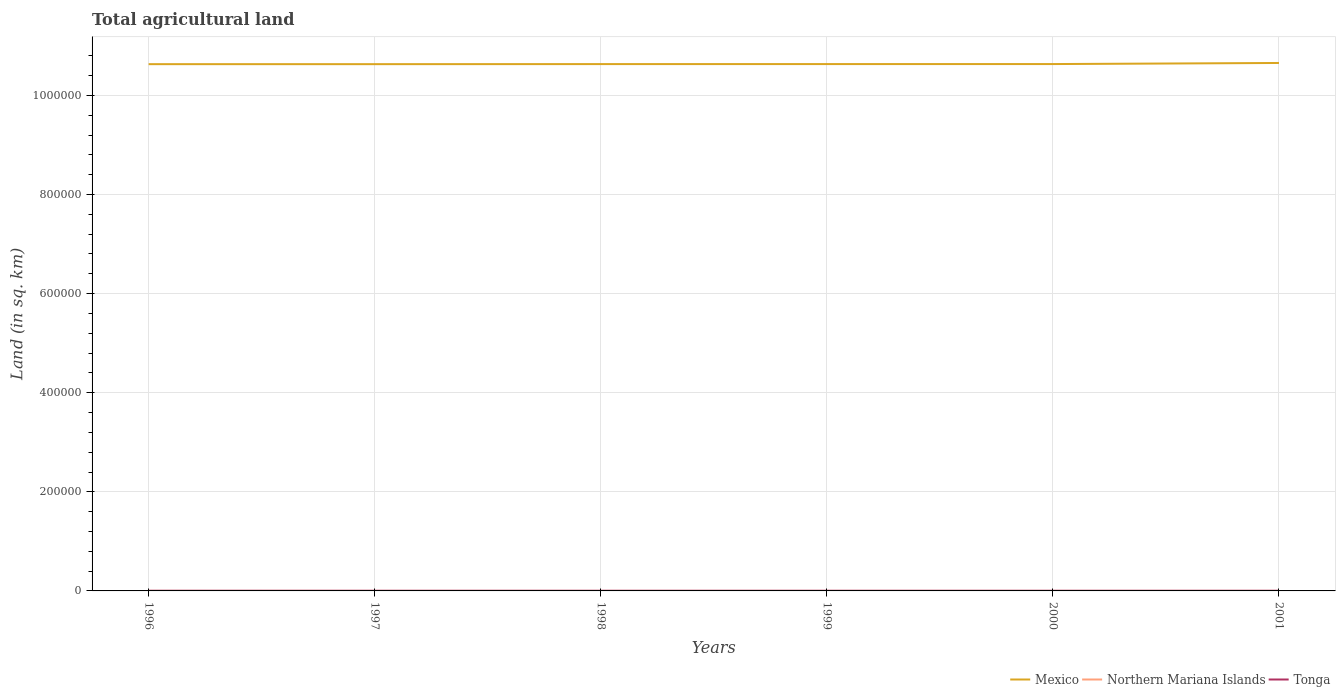How many different coloured lines are there?
Offer a very short reply. 3. Across all years, what is the maximum total agricultural land in Northern Mariana Islands?
Make the answer very short. 30. In which year was the total agricultural land in Tonga maximum?
Your answer should be very brief. 2000. What is the total total agricultural land in Mexico in the graph?
Offer a terse response. -200. What is the difference between the highest and the second highest total agricultural land in Tonga?
Provide a succinct answer. 30. What is the difference between two consecutive major ticks on the Y-axis?
Make the answer very short. 2.00e+05. Are the values on the major ticks of Y-axis written in scientific E-notation?
Keep it short and to the point. No. Does the graph contain grids?
Keep it short and to the point. Yes. How are the legend labels stacked?
Your answer should be very brief. Horizontal. What is the title of the graph?
Ensure brevity in your answer.  Total agricultural land. What is the label or title of the Y-axis?
Make the answer very short. Land (in sq. km). What is the Land (in sq. km) in Mexico in 1996?
Provide a succinct answer. 1.06e+06. What is the Land (in sq. km) of Northern Mariana Islands in 1996?
Provide a succinct answer. 40. What is the Land (in sq. km) of Tonga in 1996?
Offer a terse response. 330. What is the Land (in sq. km) in Mexico in 1997?
Keep it short and to the point. 1.06e+06. What is the Land (in sq. km) in Northern Mariana Islands in 1997?
Your answer should be compact. 40. What is the Land (in sq. km) of Tonga in 1997?
Your response must be concise. 310. What is the Land (in sq. km) of Mexico in 1998?
Provide a short and direct response. 1.06e+06. What is the Land (in sq. km) in Tonga in 1998?
Your answer should be compact. 310. What is the Land (in sq. km) of Mexico in 1999?
Keep it short and to the point. 1.06e+06. What is the Land (in sq. km) in Northern Mariana Islands in 1999?
Offer a terse response. 30. What is the Land (in sq. km) in Tonga in 1999?
Provide a short and direct response. 310. What is the Land (in sq. km) in Mexico in 2000?
Ensure brevity in your answer.  1.06e+06. What is the Land (in sq. km) in Tonga in 2000?
Your response must be concise. 300. What is the Land (in sq. km) in Mexico in 2001?
Offer a terse response. 1.07e+06. What is the Land (in sq. km) of Northern Mariana Islands in 2001?
Give a very brief answer. 30. What is the Land (in sq. km) of Tonga in 2001?
Your answer should be very brief. 300. Across all years, what is the maximum Land (in sq. km) in Mexico?
Your response must be concise. 1.07e+06. Across all years, what is the maximum Land (in sq. km) of Tonga?
Ensure brevity in your answer.  330. Across all years, what is the minimum Land (in sq. km) in Mexico?
Your answer should be compact. 1.06e+06. Across all years, what is the minimum Land (in sq. km) of Northern Mariana Islands?
Ensure brevity in your answer.  30. Across all years, what is the minimum Land (in sq. km) of Tonga?
Provide a succinct answer. 300. What is the total Land (in sq. km) of Mexico in the graph?
Give a very brief answer. 6.38e+06. What is the total Land (in sq. km) in Northern Mariana Islands in the graph?
Offer a terse response. 200. What is the total Land (in sq. km) of Tonga in the graph?
Give a very brief answer. 1860. What is the difference between the Land (in sq. km) in Mexico in 1996 and that in 1997?
Give a very brief answer. 0. What is the difference between the Land (in sq. km) in Tonga in 1996 and that in 1997?
Give a very brief answer. 20. What is the difference between the Land (in sq. km) in Mexico in 1996 and that in 1998?
Make the answer very short. -150. What is the difference between the Land (in sq. km) of Mexico in 1996 and that in 1999?
Ensure brevity in your answer.  -160. What is the difference between the Land (in sq. km) in Northern Mariana Islands in 1996 and that in 1999?
Provide a short and direct response. 10. What is the difference between the Land (in sq. km) in Tonga in 1996 and that in 1999?
Your answer should be compact. 20. What is the difference between the Land (in sq. km) in Mexico in 1996 and that in 2000?
Give a very brief answer. -200. What is the difference between the Land (in sq. km) of Mexico in 1996 and that in 2001?
Keep it short and to the point. -2400. What is the difference between the Land (in sq. km) of Mexico in 1997 and that in 1998?
Your response must be concise. -150. What is the difference between the Land (in sq. km) of Northern Mariana Islands in 1997 and that in 1998?
Your answer should be compact. 10. What is the difference between the Land (in sq. km) of Mexico in 1997 and that in 1999?
Provide a succinct answer. -160. What is the difference between the Land (in sq. km) in Northern Mariana Islands in 1997 and that in 1999?
Offer a very short reply. 10. What is the difference between the Land (in sq. km) in Mexico in 1997 and that in 2000?
Keep it short and to the point. -200. What is the difference between the Land (in sq. km) in Northern Mariana Islands in 1997 and that in 2000?
Your response must be concise. 10. What is the difference between the Land (in sq. km) in Tonga in 1997 and that in 2000?
Ensure brevity in your answer.  10. What is the difference between the Land (in sq. km) of Mexico in 1997 and that in 2001?
Your answer should be very brief. -2400. What is the difference between the Land (in sq. km) of Northern Mariana Islands in 1997 and that in 2001?
Keep it short and to the point. 10. What is the difference between the Land (in sq. km) in Northern Mariana Islands in 1998 and that in 1999?
Ensure brevity in your answer.  0. What is the difference between the Land (in sq. km) of Mexico in 1998 and that in 2000?
Give a very brief answer. -50. What is the difference between the Land (in sq. km) in Mexico in 1998 and that in 2001?
Keep it short and to the point. -2250. What is the difference between the Land (in sq. km) of Tonga in 1998 and that in 2001?
Make the answer very short. 10. What is the difference between the Land (in sq. km) of Northern Mariana Islands in 1999 and that in 2000?
Keep it short and to the point. 0. What is the difference between the Land (in sq. km) in Tonga in 1999 and that in 2000?
Make the answer very short. 10. What is the difference between the Land (in sq. km) of Mexico in 1999 and that in 2001?
Give a very brief answer. -2240. What is the difference between the Land (in sq. km) of Northern Mariana Islands in 1999 and that in 2001?
Ensure brevity in your answer.  0. What is the difference between the Land (in sq. km) in Tonga in 1999 and that in 2001?
Keep it short and to the point. 10. What is the difference between the Land (in sq. km) of Mexico in 2000 and that in 2001?
Keep it short and to the point. -2200. What is the difference between the Land (in sq. km) in Tonga in 2000 and that in 2001?
Offer a terse response. 0. What is the difference between the Land (in sq. km) of Mexico in 1996 and the Land (in sq. km) of Northern Mariana Islands in 1997?
Ensure brevity in your answer.  1.06e+06. What is the difference between the Land (in sq. km) of Mexico in 1996 and the Land (in sq. km) of Tonga in 1997?
Ensure brevity in your answer.  1.06e+06. What is the difference between the Land (in sq. km) of Northern Mariana Islands in 1996 and the Land (in sq. km) of Tonga in 1997?
Provide a succinct answer. -270. What is the difference between the Land (in sq. km) of Mexico in 1996 and the Land (in sq. km) of Northern Mariana Islands in 1998?
Provide a succinct answer. 1.06e+06. What is the difference between the Land (in sq. km) of Mexico in 1996 and the Land (in sq. km) of Tonga in 1998?
Your answer should be very brief. 1.06e+06. What is the difference between the Land (in sq. km) in Northern Mariana Islands in 1996 and the Land (in sq. km) in Tonga in 1998?
Your answer should be compact. -270. What is the difference between the Land (in sq. km) in Mexico in 1996 and the Land (in sq. km) in Northern Mariana Islands in 1999?
Offer a terse response. 1.06e+06. What is the difference between the Land (in sq. km) of Mexico in 1996 and the Land (in sq. km) of Tonga in 1999?
Give a very brief answer. 1.06e+06. What is the difference between the Land (in sq. km) of Northern Mariana Islands in 1996 and the Land (in sq. km) of Tonga in 1999?
Provide a short and direct response. -270. What is the difference between the Land (in sq. km) of Mexico in 1996 and the Land (in sq. km) of Northern Mariana Islands in 2000?
Make the answer very short. 1.06e+06. What is the difference between the Land (in sq. km) in Mexico in 1996 and the Land (in sq. km) in Tonga in 2000?
Provide a succinct answer. 1.06e+06. What is the difference between the Land (in sq. km) in Northern Mariana Islands in 1996 and the Land (in sq. km) in Tonga in 2000?
Your response must be concise. -260. What is the difference between the Land (in sq. km) of Mexico in 1996 and the Land (in sq. km) of Northern Mariana Islands in 2001?
Provide a short and direct response. 1.06e+06. What is the difference between the Land (in sq. km) in Mexico in 1996 and the Land (in sq. km) in Tonga in 2001?
Offer a very short reply. 1.06e+06. What is the difference between the Land (in sq. km) of Northern Mariana Islands in 1996 and the Land (in sq. km) of Tonga in 2001?
Offer a very short reply. -260. What is the difference between the Land (in sq. km) in Mexico in 1997 and the Land (in sq. km) in Northern Mariana Islands in 1998?
Provide a short and direct response. 1.06e+06. What is the difference between the Land (in sq. km) in Mexico in 1997 and the Land (in sq. km) in Tonga in 1998?
Provide a succinct answer. 1.06e+06. What is the difference between the Land (in sq. km) in Northern Mariana Islands in 1997 and the Land (in sq. km) in Tonga in 1998?
Ensure brevity in your answer.  -270. What is the difference between the Land (in sq. km) of Mexico in 1997 and the Land (in sq. km) of Northern Mariana Islands in 1999?
Make the answer very short. 1.06e+06. What is the difference between the Land (in sq. km) of Mexico in 1997 and the Land (in sq. km) of Tonga in 1999?
Your answer should be compact. 1.06e+06. What is the difference between the Land (in sq. km) of Northern Mariana Islands in 1997 and the Land (in sq. km) of Tonga in 1999?
Ensure brevity in your answer.  -270. What is the difference between the Land (in sq. km) in Mexico in 1997 and the Land (in sq. km) in Northern Mariana Islands in 2000?
Ensure brevity in your answer.  1.06e+06. What is the difference between the Land (in sq. km) in Mexico in 1997 and the Land (in sq. km) in Tonga in 2000?
Provide a succinct answer. 1.06e+06. What is the difference between the Land (in sq. km) of Northern Mariana Islands in 1997 and the Land (in sq. km) of Tonga in 2000?
Ensure brevity in your answer.  -260. What is the difference between the Land (in sq. km) of Mexico in 1997 and the Land (in sq. km) of Northern Mariana Islands in 2001?
Keep it short and to the point. 1.06e+06. What is the difference between the Land (in sq. km) of Mexico in 1997 and the Land (in sq. km) of Tonga in 2001?
Provide a short and direct response. 1.06e+06. What is the difference between the Land (in sq. km) of Northern Mariana Islands in 1997 and the Land (in sq. km) of Tonga in 2001?
Your answer should be compact. -260. What is the difference between the Land (in sq. km) of Mexico in 1998 and the Land (in sq. km) of Northern Mariana Islands in 1999?
Provide a succinct answer. 1.06e+06. What is the difference between the Land (in sq. km) of Mexico in 1998 and the Land (in sq. km) of Tonga in 1999?
Offer a terse response. 1.06e+06. What is the difference between the Land (in sq. km) in Northern Mariana Islands in 1998 and the Land (in sq. km) in Tonga in 1999?
Your answer should be very brief. -280. What is the difference between the Land (in sq. km) of Mexico in 1998 and the Land (in sq. km) of Northern Mariana Islands in 2000?
Keep it short and to the point. 1.06e+06. What is the difference between the Land (in sq. km) of Mexico in 1998 and the Land (in sq. km) of Tonga in 2000?
Ensure brevity in your answer.  1.06e+06. What is the difference between the Land (in sq. km) in Northern Mariana Islands in 1998 and the Land (in sq. km) in Tonga in 2000?
Offer a terse response. -270. What is the difference between the Land (in sq. km) in Mexico in 1998 and the Land (in sq. km) in Northern Mariana Islands in 2001?
Give a very brief answer. 1.06e+06. What is the difference between the Land (in sq. km) in Mexico in 1998 and the Land (in sq. km) in Tonga in 2001?
Offer a very short reply. 1.06e+06. What is the difference between the Land (in sq. km) in Northern Mariana Islands in 1998 and the Land (in sq. km) in Tonga in 2001?
Your response must be concise. -270. What is the difference between the Land (in sq. km) of Mexico in 1999 and the Land (in sq. km) of Northern Mariana Islands in 2000?
Offer a very short reply. 1.06e+06. What is the difference between the Land (in sq. km) in Mexico in 1999 and the Land (in sq. km) in Tonga in 2000?
Ensure brevity in your answer.  1.06e+06. What is the difference between the Land (in sq. km) in Northern Mariana Islands in 1999 and the Land (in sq. km) in Tonga in 2000?
Give a very brief answer. -270. What is the difference between the Land (in sq. km) in Mexico in 1999 and the Land (in sq. km) in Northern Mariana Islands in 2001?
Make the answer very short. 1.06e+06. What is the difference between the Land (in sq. km) of Mexico in 1999 and the Land (in sq. km) of Tonga in 2001?
Your answer should be very brief. 1.06e+06. What is the difference between the Land (in sq. km) of Northern Mariana Islands in 1999 and the Land (in sq. km) of Tonga in 2001?
Offer a very short reply. -270. What is the difference between the Land (in sq. km) in Mexico in 2000 and the Land (in sq. km) in Northern Mariana Islands in 2001?
Your response must be concise. 1.06e+06. What is the difference between the Land (in sq. km) in Mexico in 2000 and the Land (in sq. km) in Tonga in 2001?
Your answer should be compact. 1.06e+06. What is the difference between the Land (in sq. km) of Northern Mariana Islands in 2000 and the Land (in sq. km) of Tonga in 2001?
Your answer should be compact. -270. What is the average Land (in sq. km) in Mexico per year?
Your answer should be compact. 1.06e+06. What is the average Land (in sq. km) of Northern Mariana Islands per year?
Give a very brief answer. 33.33. What is the average Land (in sq. km) of Tonga per year?
Your answer should be very brief. 310. In the year 1996, what is the difference between the Land (in sq. km) of Mexico and Land (in sq. km) of Northern Mariana Islands?
Keep it short and to the point. 1.06e+06. In the year 1996, what is the difference between the Land (in sq. km) of Mexico and Land (in sq. km) of Tonga?
Your response must be concise. 1.06e+06. In the year 1996, what is the difference between the Land (in sq. km) of Northern Mariana Islands and Land (in sq. km) of Tonga?
Provide a succinct answer. -290. In the year 1997, what is the difference between the Land (in sq. km) of Mexico and Land (in sq. km) of Northern Mariana Islands?
Give a very brief answer. 1.06e+06. In the year 1997, what is the difference between the Land (in sq. km) in Mexico and Land (in sq. km) in Tonga?
Keep it short and to the point. 1.06e+06. In the year 1997, what is the difference between the Land (in sq. km) of Northern Mariana Islands and Land (in sq. km) of Tonga?
Provide a short and direct response. -270. In the year 1998, what is the difference between the Land (in sq. km) of Mexico and Land (in sq. km) of Northern Mariana Islands?
Provide a short and direct response. 1.06e+06. In the year 1998, what is the difference between the Land (in sq. km) in Mexico and Land (in sq. km) in Tonga?
Ensure brevity in your answer.  1.06e+06. In the year 1998, what is the difference between the Land (in sq. km) in Northern Mariana Islands and Land (in sq. km) in Tonga?
Your answer should be very brief. -280. In the year 1999, what is the difference between the Land (in sq. km) in Mexico and Land (in sq. km) in Northern Mariana Islands?
Your answer should be very brief. 1.06e+06. In the year 1999, what is the difference between the Land (in sq. km) of Mexico and Land (in sq. km) of Tonga?
Your answer should be very brief. 1.06e+06. In the year 1999, what is the difference between the Land (in sq. km) of Northern Mariana Islands and Land (in sq. km) of Tonga?
Keep it short and to the point. -280. In the year 2000, what is the difference between the Land (in sq. km) of Mexico and Land (in sq. km) of Northern Mariana Islands?
Provide a short and direct response. 1.06e+06. In the year 2000, what is the difference between the Land (in sq. km) in Mexico and Land (in sq. km) in Tonga?
Your response must be concise. 1.06e+06. In the year 2000, what is the difference between the Land (in sq. km) of Northern Mariana Islands and Land (in sq. km) of Tonga?
Your answer should be very brief. -270. In the year 2001, what is the difference between the Land (in sq. km) of Mexico and Land (in sq. km) of Northern Mariana Islands?
Keep it short and to the point. 1.07e+06. In the year 2001, what is the difference between the Land (in sq. km) of Mexico and Land (in sq. km) of Tonga?
Your answer should be very brief. 1.07e+06. In the year 2001, what is the difference between the Land (in sq. km) of Northern Mariana Islands and Land (in sq. km) of Tonga?
Provide a succinct answer. -270. What is the ratio of the Land (in sq. km) in Northern Mariana Islands in 1996 to that in 1997?
Offer a very short reply. 1. What is the ratio of the Land (in sq. km) of Tonga in 1996 to that in 1997?
Your response must be concise. 1.06. What is the ratio of the Land (in sq. km) in Northern Mariana Islands in 1996 to that in 1998?
Your response must be concise. 1.33. What is the ratio of the Land (in sq. km) in Tonga in 1996 to that in 1998?
Give a very brief answer. 1.06. What is the ratio of the Land (in sq. km) of Mexico in 1996 to that in 1999?
Your response must be concise. 1. What is the ratio of the Land (in sq. km) in Tonga in 1996 to that in 1999?
Offer a terse response. 1.06. What is the ratio of the Land (in sq. km) in Northern Mariana Islands in 1996 to that in 2000?
Offer a terse response. 1.33. What is the ratio of the Land (in sq. km) in Northern Mariana Islands in 1996 to that in 2001?
Provide a succinct answer. 1.33. What is the ratio of the Land (in sq. km) of Mexico in 1997 to that in 1998?
Provide a succinct answer. 1. What is the ratio of the Land (in sq. km) in Tonga in 1997 to that in 1998?
Give a very brief answer. 1. What is the ratio of the Land (in sq. km) in Mexico in 1997 to that in 2000?
Provide a short and direct response. 1. What is the ratio of the Land (in sq. km) in Northern Mariana Islands in 1997 to that in 2000?
Offer a terse response. 1.33. What is the ratio of the Land (in sq. km) in Mexico in 1997 to that in 2001?
Provide a succinct answer. 1. What is the ratio of the Land (in sq. km) in Northern Mariana Islands in 1997 to that in 2001?
Offer a very short reply. 1.33. What is the ratio of the Land (in sq. km) in Tonga in 1997 to that in 2001?
Keep it short and to the point. 1.03. What is the ratio of the Land (in sq. km) of Northern Mariana Islands in 1998 to that in 1999?
Your answer should be compact. 1. What is the ratio of the Land (in sq. km) in Northern Mariana Islands in 1998 to that in 2000?
Your answer should be compact. 1. What is the ratio of the Land (in sq. km) in Mexico in 1998 to that in 2001?
Provide a short and direct response. 1. What is the ratio of the Land (in sq. km) of Northern Mariana Islands in 1998 to that in 2001?
Your answer should be very brief. 1. What is the ratio of the Land (in sq. km) of Tonga in 1998 to that in 2001?
Provide a short and direct response. 1.03. What is the ratio of the Land (in sq. km) of Northern Mariana Islands in 1999 to that in 2000?
Provide a succinct answer. 1. What is the ratio of the Land (in sq. km) in Mexico in 1999 to that in 2001?
Your answer should be very brief. 1. What is the difference between the highest and the second highest Land (in sq. km) of Mexico?
Your answer should be compact. 2200. What is the difference between the highest and the second highest Land (in sq. km) of Northern Mariana Islands?
Ensure brevity in your answer.  0. What is the difference between the highest and the lowest Land (in sq. km) in Mexico?
Provide a short and direct response. 2400. What is the difference between the highest and the lowest Land (in sq. km) in Tonga?
Provide a succinct answer. 30. 